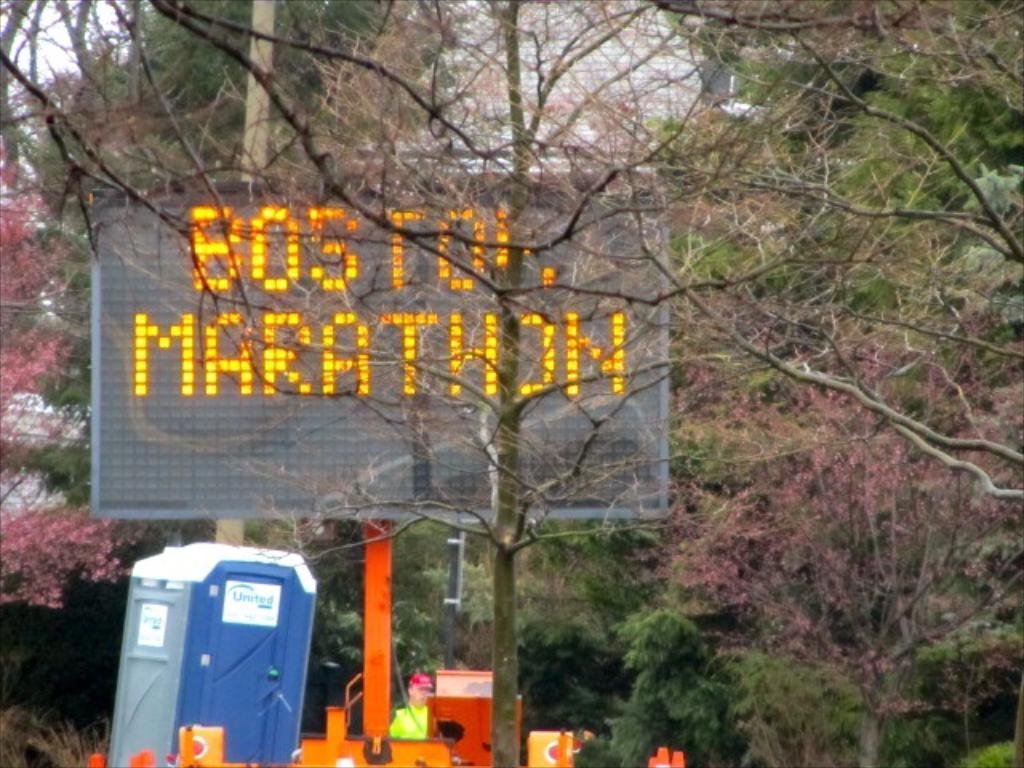What marathon is being run?
Offer a very short reply. Boston. 